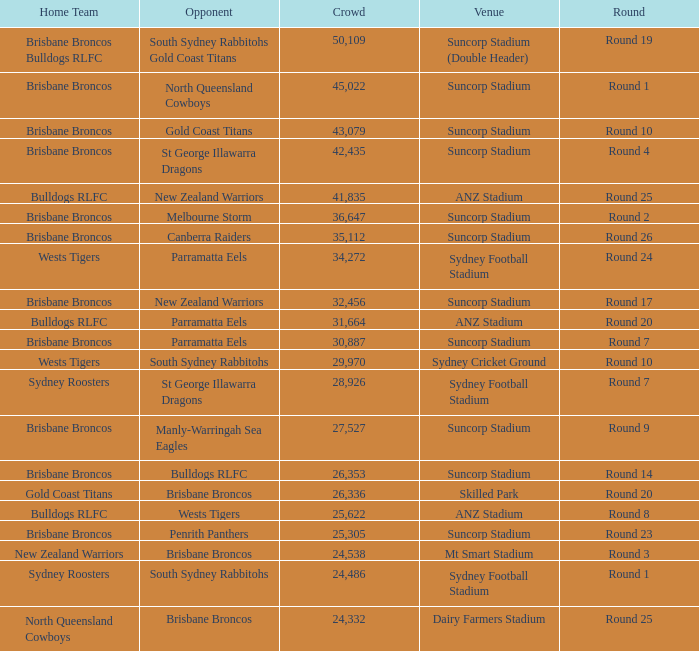What was the attendance at Round 9? 1.0. 